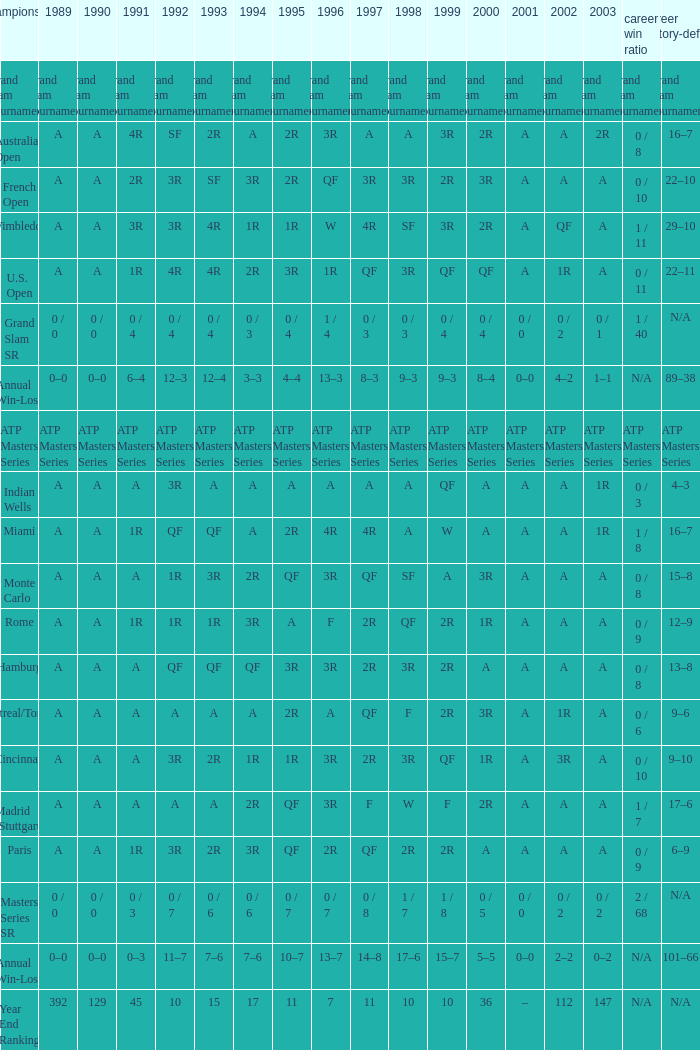What was the 1997 value when 2002 was A and 2003 was 1R? A, 4R. 